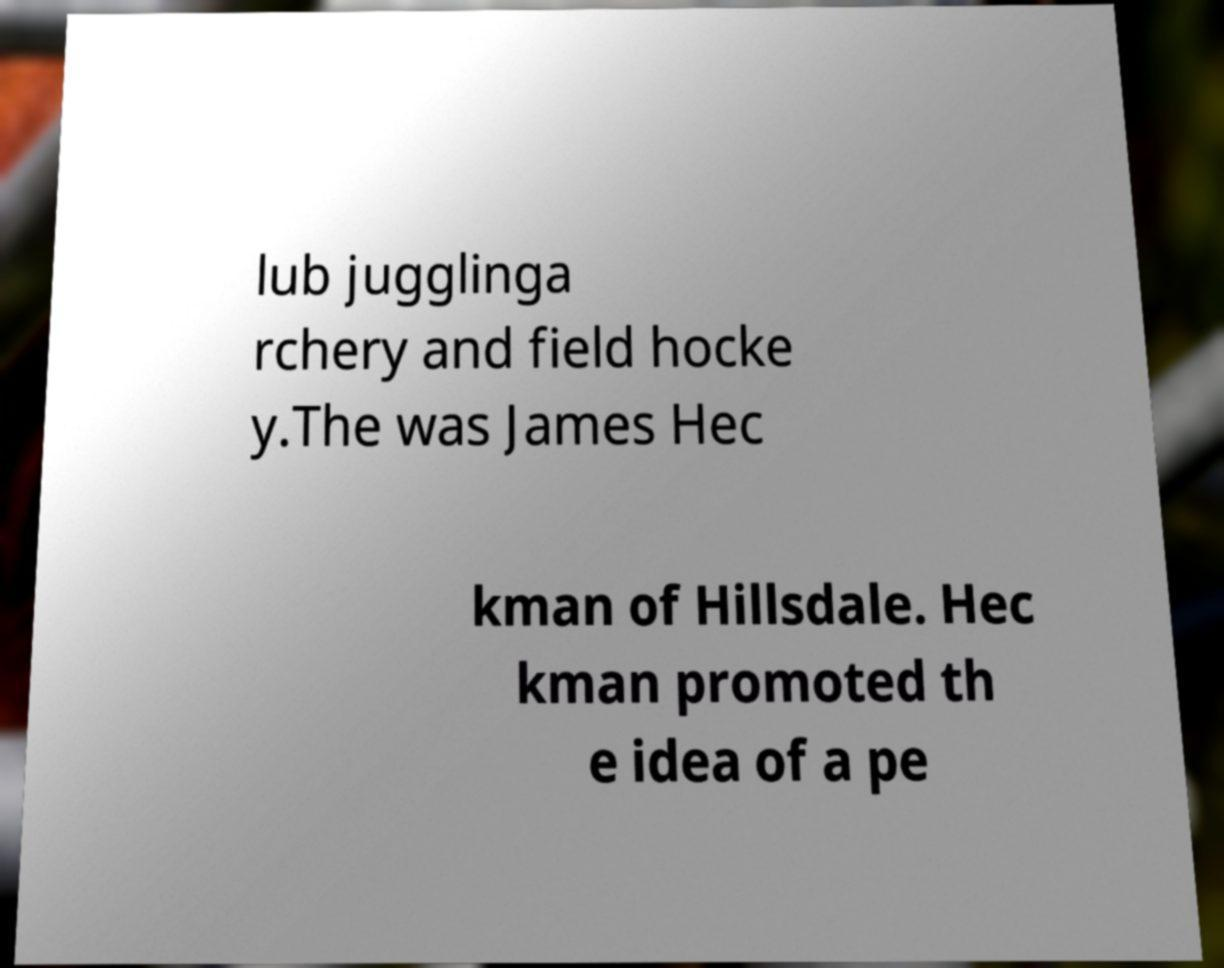Could you extract and type out the text from this image? lub jugglinga rchery and field hocke y.The was James Hec kman of Hillsdale. Hec kman promoted th e idea of a pe 